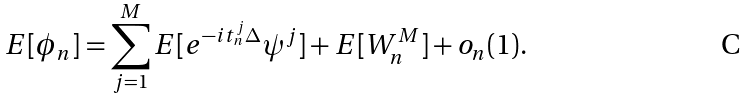<formula> <loc_0><loc_0><loc_500><loc_500>E [ \phi _ { n } ] = \sum _ { j = 1 } ^ { M } E [ e ^ { - i t ^ { j } _ { n } \Delta } \psi ^ { j } ] + E [ W ^ { M } _ { n } ] + o _ { n } ( 1 ) .</formula> 